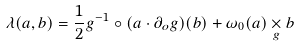<formula> <loc_0><loc_0><loc_500><loc_500>\lambda ( a , b ) = \frac { 1 } { 2 } g ^ { - 1 } \circ ( a \cdot \partial _ { o } g ) ( b ) + \omega _ { 0 } ( a ) \underset { g } { \times } b</formula> 